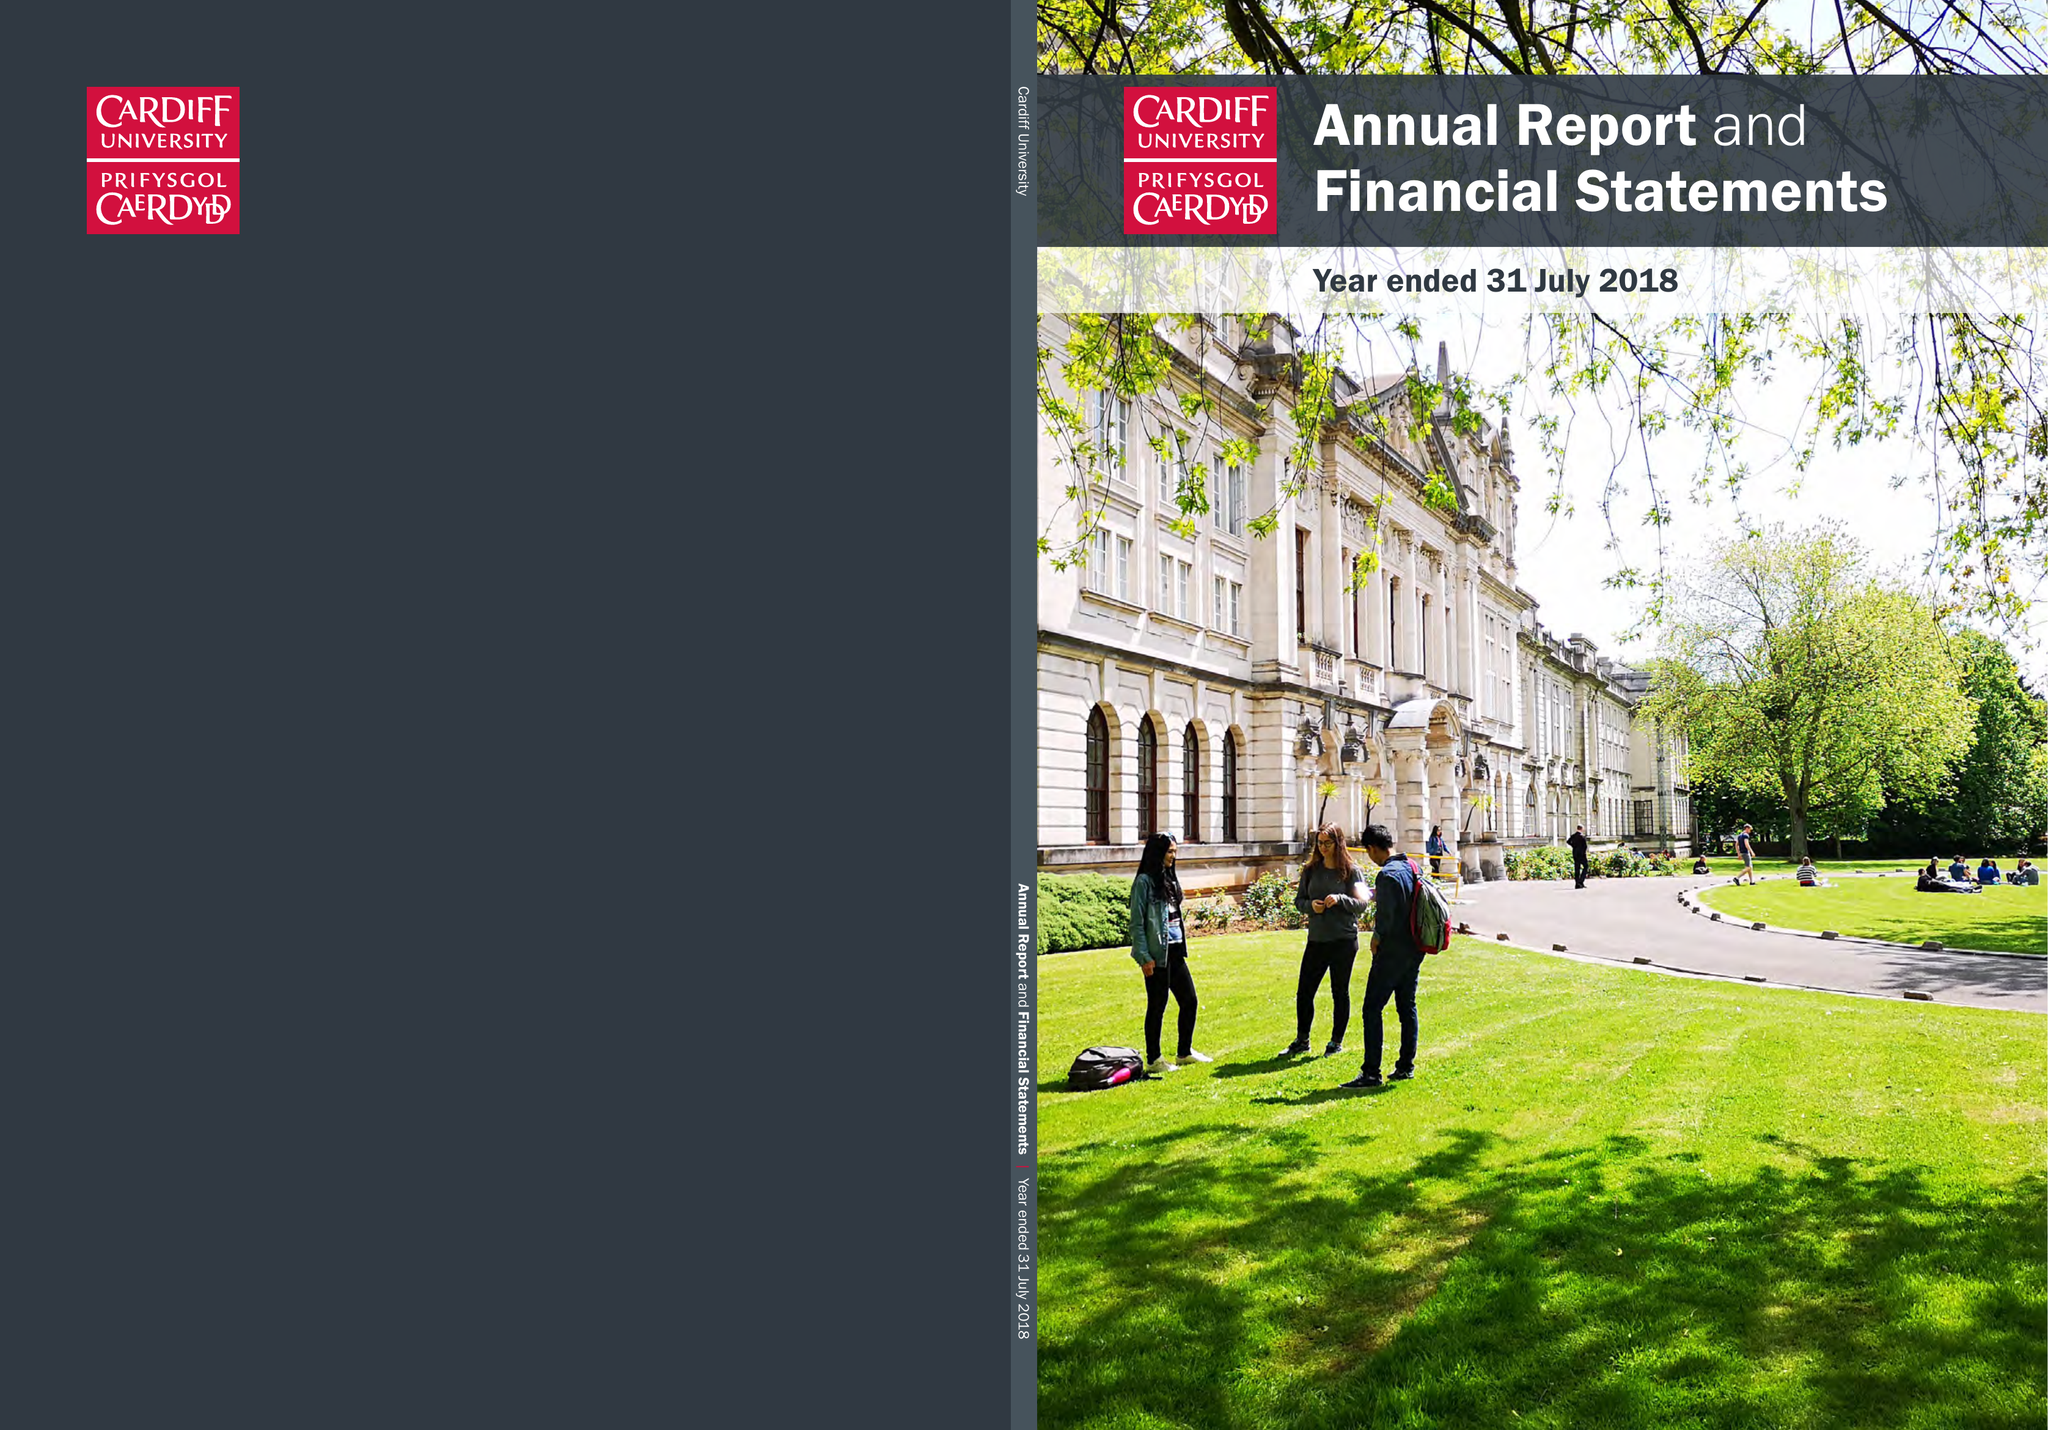What is the value for the address__postcode?
Answer the question using a single word or phrase. CF10 3AE 